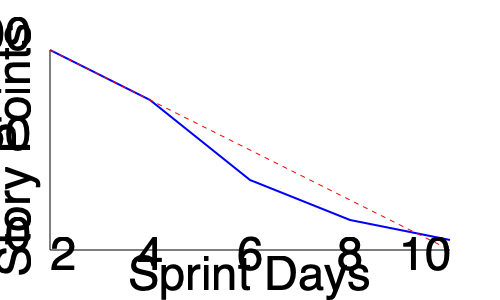Based on the burndown chart shown, which of the following statements is most accurate regarding the project's progress?

A) The project is ahead of schedule
B) The project is behind schedule
C) The project is exactly on schedule
D) The project started behind but is catching up To analyze the burndown chart and determine the project's progress, we need to follow these steps:

1. Understand the components of the chart:
   - The x-axis represents Sprint Days (from 2 to 10)
   - The y-axis represents Story Points (from 0 to 100)
   - The red dashed line represents the ideal burndown rate
   - The blue solid line represents the actual progress

2. Compare the actual progress (blue line) to the ideal burndown (red dashed line):
   - At the beginning of the sprint, both lines start at the same point
   - As the sprint progresses, the blue line stays above the red dashed line

3. Interpret the relationship between the lines:
   - When the actual progress line is above the ideal line, it means fewer story points have been completed than planned
   - This indicates that the project is moving slower than the ideal pace

4. Assess the overall trend:
   - The blue line is consistently above the red dashed line throughout the sprint
   - There is no significant convergence of the two lines towards the end of the sprint

5. Draw a conclusion:
   - Since the actual progress line (blue) remains above the ideal line (red dashed) throughout the sprint, the project is consistently behind schedule

Based on this analysis, the most accurate statement is that the project is behind schedule.
Answer: B) The project is behind schedule 